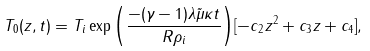<formula> <loc_0><loc_0><loc_500><loc_500>T _ { 0 } ( z , t ) = T _ { i } \exp { \left ( \frac { - ( \gamma - 1 ) \lambda \tilde { \mu } \kappa { t } } { R \rho _ { i } } \right ) } [ { - c } _ { 2 } z ^ { 2 } + c _ { 3 } z + c _ { 4 } ] ,</formula> 